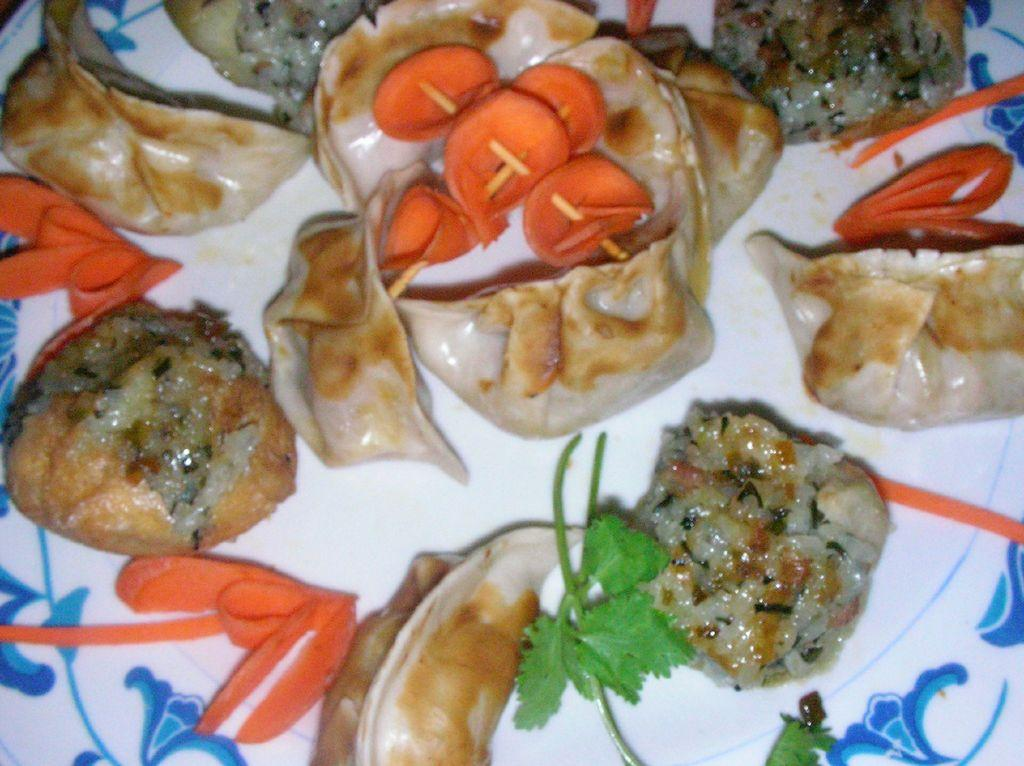What is present on the plate in the image? There are food items served on a plate in the image. Can you tell me how many jellyfish are swimming in the food on the plate? There are no jellyfish present in the image; it features food items served on a plate. 